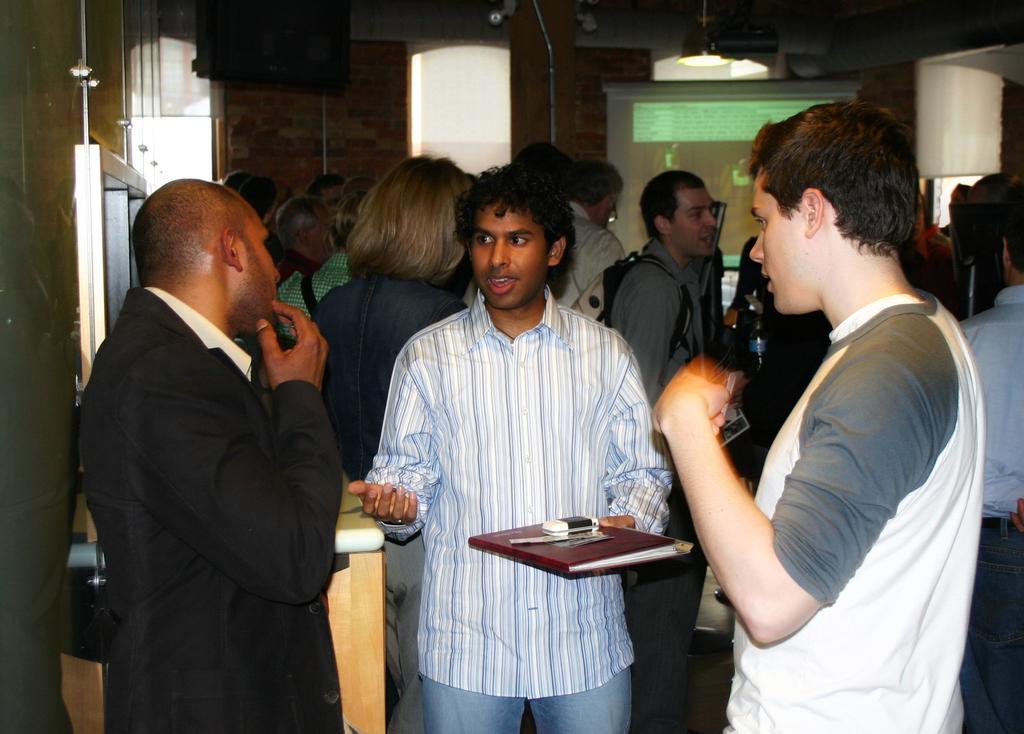Can you describe this image briefly? In this picture I can see group of people are standing on the floor. The person in the middle is holding an object in the hand. In the background I can see wall, light and projector screen. 